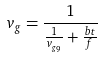<formula> <loc_0><loc_0><loc_500><loc_500>v _ { g } = \frac { 1 } { \frac { 1 } { v _ { g _ { 9 } } } + \frac { b t } { f } }</formula> 